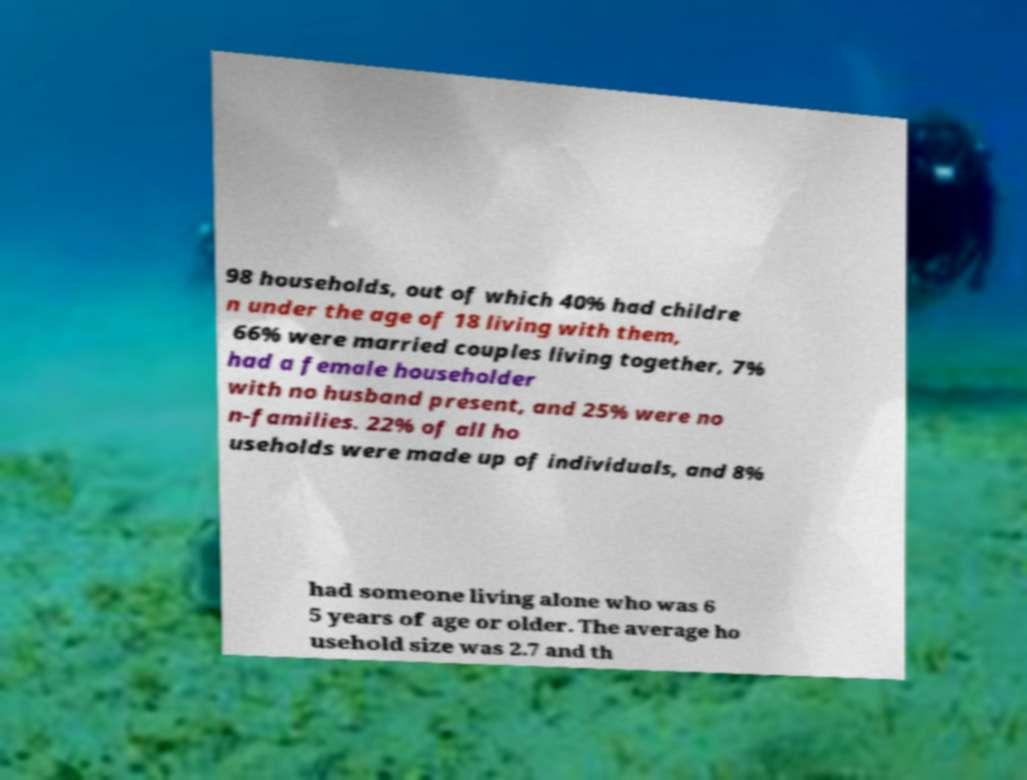Could you assist in decoding the text presented in this image and type it out clearly? 98 households, out of which 40% had childre n under the age of 18 living with them, 66% were married couples living together, 7% had a female householder with no husband present, and 25% were no n-families. 22% of all ho useholds were made up of individuals, and 8% had someone living alone who was 6 5 years of age or older. The average ho usehold size was 2.7 and th 